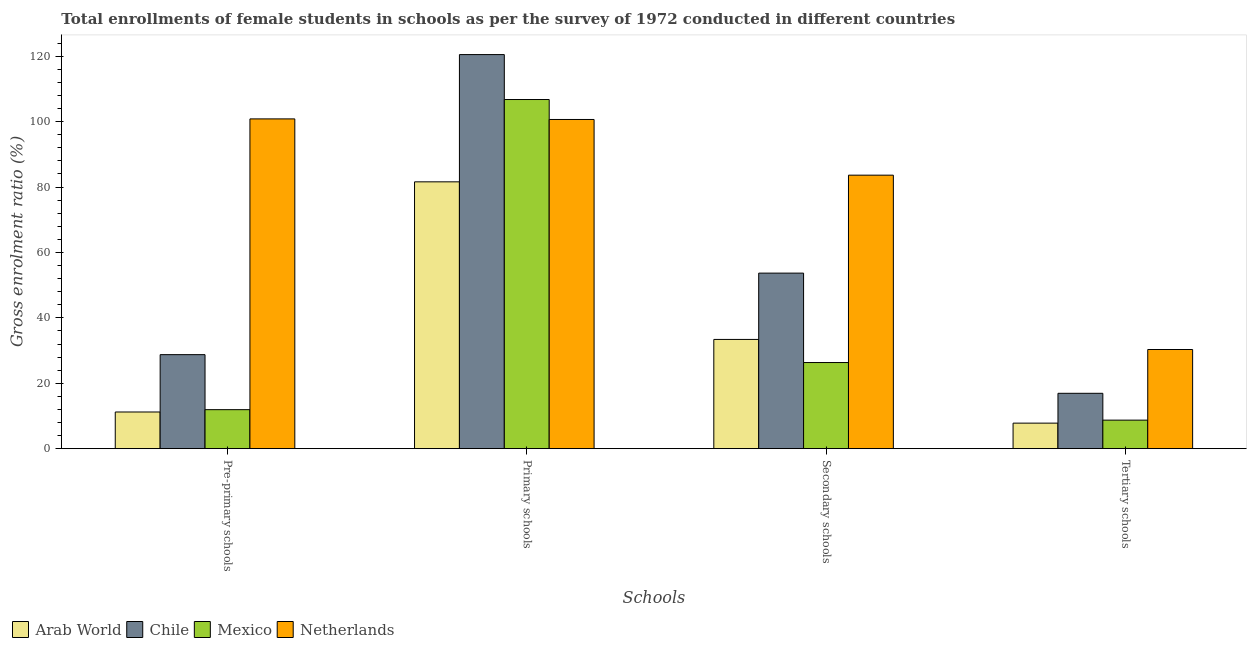How many different coloured bars are there?
Provide a succinct answer. 4. How many groups of bars are there?
Your answer should be compact. 4. Are the number of bars per tick equal to the number of legend labels?
Offer a terse response. Yes. What is the label of the 3rd group of bars from the left?
Your answer should be compact. Secondary schools. What is the gross enrolment ratio(female) in pre-primary schools in Netherlands?
Make the answer very short. 100.85. Across all countries, what is the maximum gross enrolment ratio(female) in primary schools?
Keep it short and to the point. 120.51. Across all countries, what is the minimum gross enrolment ratio(female) in tertiary schools?
Offer a terse response. 7.81. In which country was the gross enrolment ratio(female) in tertiary schools minimum?
Make the answer very short. Arab World. What is the total gross enrolment ratio(female) in secondary schools in the graph?
Give a very brief answer. 197.07. What is the difference between the gross enrolment ratio(female) in tertiary schools in Arab World and that in Chile?
Make the answer very short. -9.12. What is the difference between the gross enrolment ratio(female) in pre-primary schools in Netherlands and the gross enrolment ratio(female) in primary schools in Chile?
Provide a short and direct response. -19.67. What is the average gross enrolment ratio(female) in secondary schools per country?
Your answer should be very brief. 49.27. What is the difference between the gross enrolment ratio(female) in tertiary schools and gross enrolment ratio(female) in primary schools in Netherlands?
Offer a very short reply. -70.34. What is the ratio of the gross enrolment ratio(female) in tertiary schools in Mexico to that in Chile?
Offer a terse response. 0.52. Is the difference between the gross enrolment ratio(female) in pre-primary schools in Arab World and Chile greater than the difference between the gross enrolment ratio(female) in tertiary schools in Arab World and Chile?
Provide a succinct answer. No. What is the difference between the highest and the second highest gross enrolment ratio(female) in pre-primary schools?
Make the answer very short. 72.09. What is the difference between the highest and the lowest gross enrolment ratio(female) in primary schools?
Give a very brief answer. 38.92. In how many countries, is the gross enrolment ratio(female) in secondary schools greater than the average gross enrolment ratio(female) in secondary schools taken over all countries?
Give a very brief answer. 2. Is the sum of the gross enrolment ratio(female) in pre-primary schools in Arab World and Mexico greater than the maximum gross enrolment ratio(female) in secondary schools across all countries?
Keep it short and to the point. No. Is it the case that in every country, the sum of the gross enrolment ratio(female) in pre-primary schools and gross enrolment ratio(female) in tertiary schools is greater than the sum of gross enrolment ratio(female) in primary schools and gross enrolment ratio(female) in secondary schools?
Your response must be concise. No. What does the 3rd bar from the left in Tertiary schools represents?
Ensure brevity in your answer.  Mexico. What does the 3rd bar from the right in Primary schools represents?
Your response must be concise. Chile. Is it the case that in every country, the sum of the gross enrolment ratio(female) in pre-primary schools and gross enrolment ratio(female) in primary schools is greater than the gross enrolment ratio(female) in secondary schools?
Offer a terse response. Yes. Are all the bars in the graph horizontal?
Offer a terse response. No. Are the values on the major ticks of Y-axis written in scientific E-notation?
Give a very brief answer. No. Where does the legend appear in the graph?
Provide a succinct answer. Bottom left. What is the title of the graph?
Provide a short and direct response. Total enrollments of female students in schools as per the survey of 1972 conducted in different countries. What is the label or title of the X-axis?
Offer a very short reply. Schools. What is the label or title of the Y-axis?
Your response must be concise. Gross enrolment ratio (%). What is the Gross enrolment ratio (%) in Arab World in Pre-primary schools?
Your answer should be very brief. 11.22. What is the Gross enrolment ratio (%) of Chile in Pre-primary schools?
Ensure brevity in your answer.  28.75. What is the Gross enrolment ratio (%) of Mexico in Pre-primary schools?
Provide a short and direct response. 11.93. What is the Gross enrolment ratio (%) in Netherlands in Pre-primary schools?
Your answer should be very brief. 100.85. What is the Gross enrolment ratio (%) in Arab World in Primary schools?
Keep it short and to the point. 81.6. What is the Gross enrolment ratio (%) in Chile in Primary schools?
Your response must be concise. 120.51. What is the Gross enrolment ratio (%) in Mexico in Primary schools?
Make the answer very short. 106.77. What is the Gross enrolment ratio (%) of Netherlands in Primary schools?
Ensure brevity in your answer.  100.67. What is the Gross enrolment ratio (%) in Arab World in Secondary schools?
Your response must be concise. 33.41. What is the Gross enrolment ratio (%) of Chile in Secondary schools?
Your response must be concise. 53.68. What is the Gross enrolment ratio (%) of Mexico in Secondary schools?
Your response must be concise. 26.34. What is the Gross enrolment ratio (%) in Netherlands in Secondary schools?
Offer a terse response. 83.64. What is the Gross enrolment ratio (%) in Arab World in Tertiary schools?
Make the answer very short. 7.81. What is the Gross enrolment ratio (%) of Chile in Tertiary schools?
Provide a short and direct response. 16.93. What is the Gross enrolment ratio (%) of Mexico in Tertiary schools?
Your answer should be very brief. 8.73. What is the Gross enrolment ratio (%) in Netherlands in Tertiary schools?
Keep it short and to the point. 30.33. Across all Schools, what is the maximum Gross enrolment ratio (%) of Arab World?
Offer a terse response. 81.6. Across all Schools, what is the maximum Gross enrolment ratio (%) of Chile?
Provide a succinct answer. 120.51. Across all Schools, what is the maximum Gross enrolment ratio (%) in Mexico?
Your answer should be very brief. 106.77. Across all Schools, what is the maximum Gross enrolment ratio (%) in Netherlands?
Offer a terse response. 100.85. Across all Schools, what is the minimum Gross enrolment ratio (%) in Arab World?
Keep it short and to the point. 7.81. Across all Schools, what is the minimum Gross enrolment ratio (%) of Chile?
Offer a very short reply. 16.93. Across all Schools, what is the minimum Gross enrolment ratio (%) in Mexico?
Keep it short and to the point. 8.73. Across all Schools, what is the minimum Gross enrolment ratio (%) of Netherlands?
Offer a terse response. 30.33. What is the total Gross enrolment ratio (%) of Arab World in the graph?
Offer a terse response. 134.03. What is the total Gross enrolment ratio (%) of Chile in the graph?
Provide a succinct answer. 219.88. What is the total Gross enrolment ratio (%) of Mexico in the graph?
Offer a very short reply. 153.77. What is the total Gross enrolment ratio (%) of Netherlands in the graph?
Your answer should be compact. 315.48. What is the difference between the Gross enrolment ratio (%) in Arab World in Pre-primary schools and that in Primary schools?
Your answer should be very brief. -70.38. What is the difference between the Gross enrolment ratio (%) of Chile in Pre-primary schools and that in Primary schools?
Offer a very short reply. -91.76. What is the difference between the Gross enrolment ratio (%) in Mexico in Pre-primary schools and that in Primary schools?
Keep it short and to the point. -94.84. What is the difference between the Gross enrolment ratio (%) of Netherlands in Pre-primary schools and that in Primary schools?
Your answer should be compact. 0.18. What is the difference between the Gross enrolment ratio (%) of Arab World in Pre-primary schools and that in Secondary schools?
Offer a terse response. -22.19. What is the difference between the Gross enrolment ratio (%) in Chile in Pre-primary schools and that in Secondary schools?
Provide a short and direct response. -24.93. What is the difference between the Gross enrolment ratio (%) of Mexico in Pre-primary schools and that in Secondary schools?
Provide a short and direct response. -14.41. What is the difference between the Gross enrolment ratio (%) of Netherlands in Pre-primary schools and that in Secondary schools?
Your answer should be very brief. 17.21. What is the difference between the Gross enrolment ratio (%) in Arab World in Pre-primary schools and that in Tertiary schools?
Offer a very short reply. 3.41. What is the difference between the Gross enrolment ratio (%) in Chile in Pre-primary schools and that in Tertiary schools?
Provide a succinct answer. 11.82. What is the difference between the Gross enrolment ratio (%) of Mexico in Pre-primary schools and that in Tertiary schools?
Offer a terse response. 3.2. What is the difference between the Gross enrolment ratio (%) of Netherlands in Pre-primary schools and that in Tertiary schools?
Your answer should be very brief. 70.52. What is the difference between the Gross enrolment ratio (%) of Arab World in Primary schools and that in Secondary schools?
Give a very brief answer. 48.19. What is the difference between the Gross enrolment ratio (%) of Chile in Primary schools and that in Secondary schools?
Make the answer very short. 66.83. What is the difference between the Gross enrolment ratio (%) of Mexico in Primary schools and that in Secondary schools?
Offer a very short reply. 80.43. What is the difference between the Gross enrolment ratio (%) in Netherlands in Primary schools and that in Secondary schools?
Offer a terse response. 17.03. What is the difference between the Gross enrolment ratio (%) in Arab World in Primary schools and that in Tertiary schools?
Provide a succinct answer. 73.79. What is the difference between the Gross enrolment ratio (%) in Chile in Primary schools and that in Tertiary schools?
Provide a short and direct response. 103.58. What is the difference between the Gross enrolment ratio (%) of Mexico in Primary schools and that in Tertiary schools?
Provide a succinct answer. 98.04. What is the difference between the Gross enrolment ratio (%) of Netherlands in Primary schools and that in Tertiary schools?
Ensure brevity in your answer.  70.34. What is the difference between the Gross enrolment ratio (%) in Arab World in Secondary schools and that in Tertiary schools?
Give a very brief answer. 25.6. What is the difference between the Gross enrolment ratio (%) in Chile in Secondary schools and that in Tertiary schools?
Your response must be concise. 36.75. What is the difference between the Gross enrolment ratio (%) in Mexico in Secondary schools and that in Tertiary schools?
Offer a very short reply. 17.61. What is the difference between the Gross enrolment ratio (%) in Netherlands in Secondary schools and that in Tertiary schools?
Make the answer very short. 53.31. What is the difference between the Gross enrolment ratio (%) of Arab World in Pre-primary schools and the Gross enrolment ratio (%) of Chile in Primary schools?
Keep it short and to the point. -109.3. What is the difference between the Gross enrolment ratio (%) of Arab World in Pre-primary schools and the Gross enrolment ratio (%) of Mexico in Primary schools?
Keep it short and to the point. -95.55. What is the difference between the Gross enrolment ratio (%) in Arab World in Pre-primary schools and the Gross enrolment ratio (%) in Netherlands in Primary schools?
Give a very brief answer. -89.45. What is the difference between the Gross enrolment ratio (%) of Chile in Pre-primary schools and the Gross enrolment ratio (%) of Mexico in Primary schools?
Your response must be concise. -78.02. What is the difference between the Gross enrolment ratio (%) in Chile in Pre-primary schools and the Gross enrolment ratio (%) in Netherlands in Primary schools?
Provide a succinct answer. -71.91. What is the difference between the Gross enrolment ratio (%) of Mexico in Pre-primary schools and the Gross enrolment ratio (%) of Netherlands in Primary schools?
Give a very brief answer. -88.74. What is the difference between the Gross enrolment ratio (%) of Arab World in Pre-primary schools and the Gross enrolment ratio (%) of Chile in Secondary schools?
Provide a short and direct response. -42.47. What is the difference between the Gross enrolment ratio (%) in Arab World in Pre-primary schools and the Gross enrolment ratio (%) in Mexico in Secondary schools?
Your answer should be very brief. -15.12. What is the difference between the Gross enrolment ratio (%) of Arab World in Pre-primary schools and the Gross enrolment ratio (%) of Netherlands in Secondary schools?
Give a very brief answer. -72.42. What is the difference between the Gross enrolment ratio (%) of Chile in Pre-primary schools and the Gross enrolment ratio (%) of Mexico in Secondary schools?
Make the answer very short. 2.41. What is the difference between the Gross enrolment ratio (%) in Chile in Pre-primary schools and the Gross enrolment ratio (%) in Netherlands in Secondary schools?
Give a very brief answer. -54.89. What is the difference between the Gross enrolment ratio (%) of Mexico in Pre-primary schools and the Gross enrolment ratio (%) of Netherlands in Secondary schools?
Ensure brevity in your answer.  -71.71. What is the difference between the Gross enrolment ratio (%) of Arab World in Pre-primary schools and the Gross enrolment ratio (%) of Chile in Tertiary schools?
Offer a terse response. -5.71. What is the difference between the Gross enrolment ratio (%) of Arab World in Pre-primary schools and the Gross enrolment ratio (%) of Mexico in Tertiary schools?
Keep it short and to the point. 2.49. What is the difference between the Gross enrolment ratio (%) of Arab World in Pre-primary schools and the Gross enrolment ratio (%) of Netherlands in Tertiary schools?
Offer a very short reply. -19.11. What is the difference between the Gross enrolment ratio (%) of Chile in Pre-primary schools and the Gross enrolment ratio (%) of Mexico in Tertiary schools?
Provide a succinct answer. 20.03. What is the difference between the Gross enrolment ratio (%) in Chile in Pre-primary schools and the Gross enrolment ratio (%) in Netherlands in Tertiary schools?
Keep it short and to the point. -1.57. What is the difference between the Gross enrolment ratio (%) of Mexico in Pre-primary schools and the Gross enrolment ratio (%) of Netherlands in Tertiary schools?
Keep it short and to the point. -18.4. What is the difference between the Gross enrolment ratio (%) of Arab World in Primary schools and the Gross enrolment ratio (%) of Chile in Secondary schools?
Provide a short and direct response. 27.91. What is the difference between the Gross enrolment ratio (%) of Arab World in Primary schools and the Gross enrolment ratio (%) of Mexico in Secondary schools?
Your answer should be very brief. 55.26. What is the difference between the Gross enrolment ratio (%) of Arab World in Primary schools and the Gross enrolment ratio (%) of Netherlands in Secondary schools?
Provide a succinct answer. -2.04. What is the difference between the Gross enrolment ratio (%) in Chile in Primary schools and the Gross enrolment ratio (%) in Mexico in Secondary schools?
Offer a very short reply. 94.17. What is the difference between the Gross enrolment ratio (%) of Chile in Primary schools and the Gross enrolment ratio (%) of Netherlands in Secondary schools?
Offer a terse response. 36.87. What is the difference between the Gross enrolment ratio (%) in Mexico in Primary schools and the Gross enrolment ratio (%) in Netherlands in Secondary schools?
Provide a short and direct response. 23.13. What is the difference between the Gross enrolment ratio (%) of Arab World in Primary schools and the Gross enrolment ratio (%) of Chile in Tertiary schools?
Provide a short and direct response. 64.67. What is the difference between the Gross enrolment ratio (%) in Arab World in Primary schools and the Gross enrolment ratio (%) in Mexico in Tertiary schools?
Make the answer very short. 72.87. What is the difference between the Gross enrolment ratio (%) in Arab World in Primary schools and the Gross enrolment ratio (%) in Netherlands in Tertiary schools?
Ensure brevity in your answer.  51.27. What is the difference between the Gross enrolment ratio (%) in Chile in Primary schools and the Gross enrolment ratio (%) in Mexico in Tertiary schools?
Give a very brief answer. 111.79. What is the difference between the Gross enrolment ratio (%) of Chile in Primary schools and the Gross enrolment ratio (%) of Netherlands in Tertiary schools?
Your answer should be very brief. 90.19. What is the difference between the Gross enrolment ratio (%) of Mexico in Primary schools and the Gross enrolment ratio (%) of Netherlands in Tertiary schools?
Provide a succinct answer. 76.44. What is the difference between the Gross enrolment ratio (%) in Arab World in Secondary schools and the Gross enrolment ratio (%) in Chile in Tertiary schools?
Give a very brief answer. 16.48. What is the difference between the Gross enrolment ratio (%) in Arab World in Secondary schools and the Gross enrolment ratio (%) in Mexico in Tertiary schools?
Your answer should be very brief. 24.68. What is the difference between the Gross enrolment ratio (%) of Arab World in Secondary schools and the Gross enrolment ratio (%) of Netherlands in Tertiary schools?
Your answer should be compact. 3.08. What is the difference between the Gross enrolment ratio (%) of Chile in Secondary schools and the Gross enrolment ratio (%) of Mexico in Tertiary schools?
Offer a terse response. 44.96. What is the difference between the Gross enrolment ratio (%) of Chile in Secondary schools and the Gross enrolment ratio (%) of Netherlands in Tertiary schools?
Provide a succinct answer. 23.36. What is the difference between the Gross enrolment ratio (%) of Mexico in Secondary schools and the Gross enrolment ratio (%) of Netherlands in Tertiary schools?
Give a very brief answer. -3.99. What is the average Gross enrolment ratio (%) of Arab World per Schools?
Make the answer very short. 33.51. What is the average Gross enrolment ratio (%) of Chile per Schools?
Your response must be concise. 54.97. What is the average Gross enrolment ratio (%) in Mexico per Schools?
Keep it short and to the point. 38.44. What is the average Gross enrolment ratio (%) of Netherlands per Schools?
Give a very brief answer. 78.87. What is the difference between the Gross enrolment ratio (%) of Arab World and Gross enrolment ratio (%) of Chile in Pre-primary schools?
Provide a short and direct response. -17.54. What is the difference between the Gross enrolment ratio (%) in Arab World and Gross enrolment ratio (%) in Mexico in Pre-primary schools?
Your answer should be compact. -0.71. What is the difference between the Gross enrolment ratio (%) in Arab World and Gross enrolment ratio (%) in Netherlands in Pre-primary schools?
Give a very brief answer. -89.63. What is the difference between the Gross enrolment ratio (%) in Chile and Gross enrolment ratio (%) in Mexico in Pre-primary schools?
Make the answer very short. 16.82. What is the difference between the Gross enrolment ratio (%) of Chile and Gross enrolment ratio (%) of Netherlands in Pre-primary schools?
Your answer should be compact. -72.09. What is the difference between the Gross enrolment ratio (%) in Mexico and Gross enrolment ratio (%) in Netherlands in Pre-primary schools?
Ensure brevity in your answer.  -88.92. What is the difference between the Gross enrolment ratio (%) in Arab World and Gross enrolment ratio (%) in Chile in Primary schools?
Make the answer very short. -38.92. What is the difference between the Gross enrolment ratio (%) of Arab World and Gross enrolment ratio (%) of Mexico in Primary schools?
Keep it short and to the point. -25.17. What is the difference between the Gross enrolment ratio (%) in Arab World and Gross enrolment ratio (%) in Netherlands in Primary schools?
Offer a terse response. -19.07. What is the difference between the Gross enrolment ratio (%) in Chile and Gross enrolment ratio (%) in Mexico in Primary schools?
Make the answer very short. 13.74. What is the difference between the Gross enrolment ratio (%) in Chile and Gross enrolment ratio (%) in Netherlands in Primary schools?
Provide a succinct answer. 19.85. What is the difference between the Gross enrolment ratio (%) of Mexico and Gross enrolment ratio (%) of Netherlands in Primary schools?
Your answer should be compact. 6.1. What is the difference between the Gross enrolment ratio (%) in Arab World and Gross enrolment ratio (%) in Chile in Secondary schools?
Offer a terse response. -20.28. What is the difference between the Gross enrolment ratio (%) of Arab World and Gross enrolment ratio (%) of Mexico in Secondary schools?
Provide a short and direct response. 7.07. What is the difference between the Gross enrolment ratio (%) in Arab World and Gross enrolment ratio (%) in Netherlands in Secondary schools?
Provide a short and direct response. -50.23. What is the difference between the Gross enrolment ratio (%) in Chile and Gross enrolment ratio (%) in Mexico in Secondary schools?
Offer a terse response. 27.34. What is the difference between the Gross enrolment ratio (%) of Chile and Gross enrolment ratio (%) of Netherlands in Secondary schools?
Provide a short and direct response. -29.95. What is the difference between the Gross enrolment ratio (%) in Mexico and Gross enrolment ratio (%) in Netherlands in Secondary schools?
Give a very brief answer. -57.3. What is the difference between the Gross enrolment ratio (%) of Arab World and Gross enrolment ratio (%) of Chile in Tertiary schools?
Give a very brief answer. -9.12. What is the difference between the Gross enrolment ratio (%) of Arab World and Gross enrolment ratio (%) of Mexico in Tertiary schools?
Ensure brevity in your answer.  -0.92. What is the difference between the Gross enrolment ratio (%) of Arab World and Gross enrolment ratio (%) of Netherlands in Tertiary schools?
Ensure brevity in your answer.  -22.52. What is the difference between the Gross enrolment ratio (%) of Chile and Gross enrolment ratio (%) of Mexico in Tertiary schools?
Keep it short and to the point. 8.2. What is the difference between the Gross enrolment ratio (%) of Chile and Gross enrolment ratio (%) of Netherlands in Tertiary schools?
Your answer should be very brief. -13.4. What is the difference between the Gross enrolment ratio (%) of Mexico and Gross enrolment ratio (%) of Netherlands in Tertiary schools?
Provide a short and direct response. -21.6. What is the ratio of the Gross enrolment ratio (%) of Arab World in Pre-primary schools to that in Primary schools?
Offer a terse response. 0.14. What is the ratio of the Gross enrolment ratio (%) of Chile in Pre-primary schools to that in Primary schools?
Provide a succinct answer. 0.24. What is the ratio of the Gross enrolment ratio (%) in Mexico in Pre-primary schools to that in Primary schools?
Make the answer very short. 0.11. What is the ratio of the Gross enrolment ratio (%) in Arab World in Pre-primary schools to that in Secondary schools?
Give a very brief answer. 0.34. What is the ratio of the Gross enrolment ratio (%) in Chile in Pre-primary schools to that in Secondary schools?
Provide a succinct answer. 0.54. What is the ratio of the Gross enrolment ratio (%) in Mexico in Pre-primary schools to that in Secondary schools?
Make the answer very short. 0.45. What is the ratio of the Gross enrolment ratio (%) of Netherlands in Pre-primary schools to that in Secondary schools?
Your answer should be compact. 1.21. What is the ratio of the Gross enrolment ratio (%) of Arab World in Pre-primary schools to that in Tertiary schools?
Your response must be concise. 1.44. What is the ratio of the Gross enrolment ratio (%) of Chile in Pre-primary schools to that in Tertiary schools?
Provide a short and direct response. 1.7. What is the ratio of the Gross enrolment ratio (%) in Mexico in Pre-primary schools to that in Tertiary schools?
Provide a short and direct response. 1.37. What is the ratio of the Gross enrolment ratio (%) of Netherlands in Pre-primary schools to that in Tertiary schools?
Make the answer very short. 3.33. What is the ratio of the Gross enrolment ratio (%) of Arab World in Primary schools to that in Secondary schools?
Provide a succinct answer. 2.44. What is the ratio of the Gross enrolment ratio (%) of Chile in Primary schools to that in Secondary schools?
Your answer should be very brief. 2.24. What is the ratio of the Gross enrolment ratio (%) in Mexico in Primary schools to that in Secondary schools?
Give a very brief answer. 4.05. What is the ratio of the Gross enrolment ratio (%) of Netherlands in Primary schools to that in Secondary schools?
Keep it short and to the point. 1.2. What is the ratio of the Gross enrolment ratio (%) in Arab World in Primary schools to that in Tertiary schools?
Provide a short and direct response. 10.45. What is the ratio of the Gross enrolment ratio (%) in Chile in Primary schools to that in Tertiary schools?
Ensure brevity in your answer.  7.12. What is the ratio of the Gross enrolment ratio (%) of Mexico in Primary schools to that in Tertiary schools?
Keep it short and to the point. 12.23. What is the ratio of the Gross enrolment ratio (%) of Netherlands in Primary schools to that in Tertiary schools?
Provide a short and direct response. 3.32. What is the ratio of the Gross enrolment ratio (%) of Arab World in Secondary schools to that in Tertiary schools?
Give a very brief answer. 4.28. What is the ratio of the Gross enrolment ratio (%) of Chile in Secondary schools to that in Tertiary schools?
Make the answer very short. 3.17. What is the ratio of the Gross enrolment ratio (%) in Mexico in Secondary schools to that in Tertiary schools?
Offer a very short reply. 3.02. What is the ratio of the Gross enrolment ratio (%) in Netherlands in Secondary schools to that in Tertiary schools?
Provide a succinct answer. 2.76. What is the difference between the highest and the second highest Gross enrolment ratio (%) in Arab World?
Your answer should be very brief. 48.19. What is the difference between the highest and the second highest Gross enrolment ratio (%) of Chile?
Offer a terse response. 66.83. What is the difference between the highest and the second highest Gross enrolment ratio (%) of Mexico?
Ensure brevity in your answer.  80.43. What is the difference between the highest and the second highest Gross enrolment ratio (%) in Netherlands?
Provide a succinct answer. 0.18. What is the difference between the highest and the lowest Gross enrolment ratio (%) in Arab World?
Give a very brief answer. 73.79. What is the difference between the highest and the lowest Gross enrolment ratio (%) of Chile?
Your answer should be very brief. 103.58. What is the difference between the highest and the lowest Gross enrolment ratio (%) in Mexico?
Offer a very short reply. 98.04. What is the difference between the highest and the lowest Gross enrolment ratio (%) of Netherlands?
Provide a short and direct response. 70.52. 